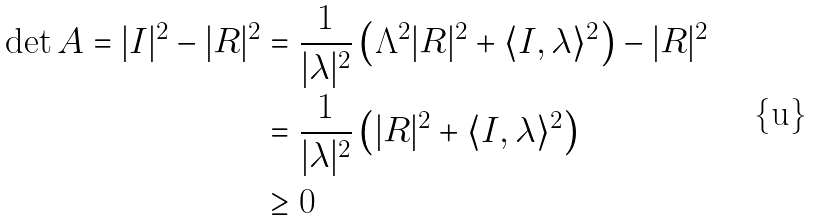Convert formula to latex. <formula><loc_0><loc_0><loc_500><loc_500>\det A = | I | ^ { 2 } - | R | ^ { 2 } & = \frac { 1 } { | \lambda | ^ { 2 } } \left ( \Lambda ^ { 2 } | R | ^ { 2 } + \langle I , \lambda \rangle ^ { 2 } \right ) - | R | ^ { 2 } \\ & = \frac { 1 } { | \lambda | ^ { 2 } } \left ( | R | ^ { 2 } + \langle I , \lambda \rangle ^ { 2 } \right ) \\ & \geq 0</formula> 